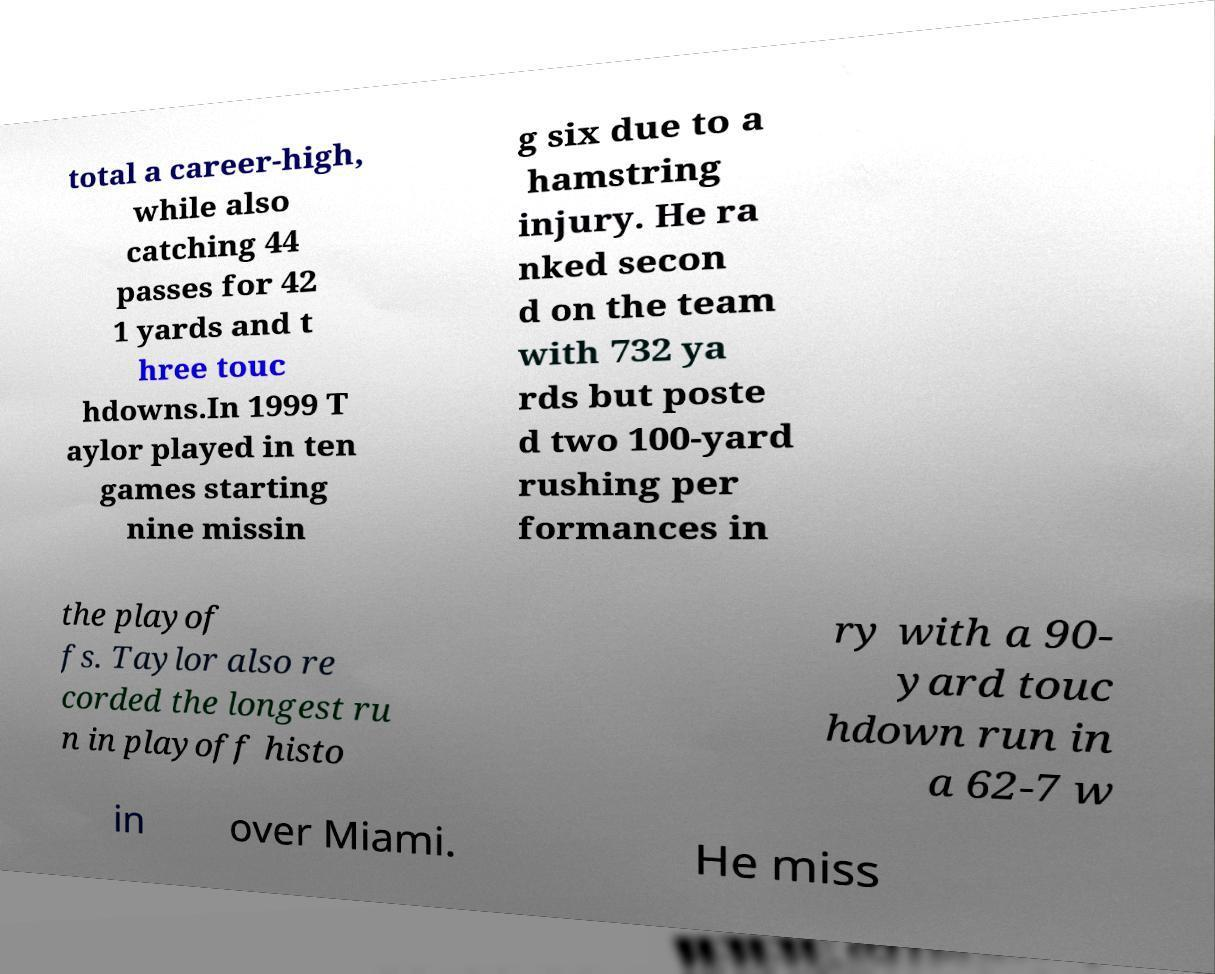Can you read and provide the text displayed in the image?This photo seems to have some interesting text. Can you extract and type it out for me? total a career-high, while also catching 44 passes for 42 1 yards and t hree touc hdowns.In 1999 T aylor played in ten games starting nine missin g six due to a hamstring injury. He ra nked secon d on the team with 732 ya rds but poste d two 100-yard rushing per formances in the playof fs. Taylor also re corded the longest ru n in playoff histo ry with a 90- yard touc hdown run in a 62-7 w in over Miami. He miss 